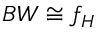Convert formula to latex. <formula><loc_0><loc_0><loc_500><loc_500>B W \cong f _ { H }</formula> 